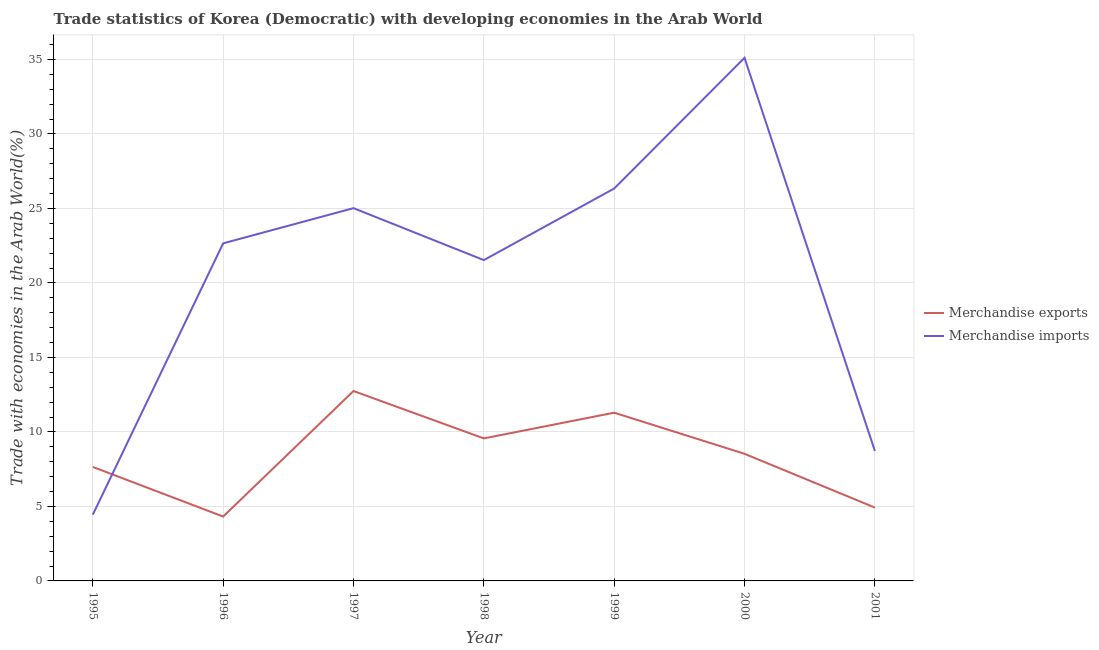How many different coloured lines are there?
Offer a terse response. 2. Does the line corresponding to merchandise exports intersect with the line corresponding to merchandise imports?
Your answer should be compact. Yes. What is the merchandise exports in 1996?
Your answer should be compact. 4.32. Across all years, what is the maximum merchandise imports?
Offer a very short reply. 35.11. Across all years, what is the minimum merchandise exports?
Your answer should be compact. 4.32. What is the total merchandise imports in the graph?
Provide a succinct answer. 143.83. What is the difference between the merchandise exports in 1996 and that in 2001?
Offer a very short reply. -0.6. What is the difference between the merchandise imports in 1998 and the merchandise exports in 1997?
Your answer should be compact. 8.79. What is the average merchandise imports per year?
Offer a terse response. 20.55. In the year 1996, what is the difference between the merchandise exports and merchandise imports?
Ensure brevity in your answer.  -18.34. What is the ratio of the merchandise exports in 1997 to that in 2000?
Provide a succinct answer. 1.49. Is the difference between the merchandise imports in 1999 and 2000 greater than the difference between the merchandise exports in 1999 and 2000?
Make the answer very short. No. What is the difference between the highest and the second highest merchandise exports?
Your answer should be compact. 1.45. What is the difference between the highest and the lowest merchandise exports?
Offer a terse response. 8.42. In how many years, is the merchandise exports greater than the average merchandise exports taken over all years?
Keep it short and to the point. 4. Is the sum of the merchandise exports in 1997 and 1998 greater than the maximum merchandise imports across all years?
Offer a terse response. No. Does the merchandise exports monotonically increase over the years?
Provide a succinct answer. No. How many years are there in the graph?
Offer a terse response. 7. Does the graph contain any zero values?
Your response must be concise. No. Where does the legend appear in the graph?
Ensure brevity in your answer.  Center right. How are the legend labels stacked?
Keep it short and to the point. Vertical. What is the title of the graph?
Your response must be concise. Trade statistics of Korea (Democratic) with developing economies in the Arab World. Does "Foreign Liabilities" appear as one of the legend labels in the graph?
Your answer should be compact. No. What is the label or title of the X-axis?
Make the answer very short. Year. What is the label or title of the Y-axis?
Offer a terse response. Trade with economies in the Arab World(%). What is the Trade with economies in the Arab World(%) in Merchandise exports in 1995?
Your answer should be very brief. 7.65. What is the Trade with economies in the Arab World(%) in Merchandise imports in 1995?
Make the answer very short. 4.45. What is the Trade with economies in the Arab World(%) of Merchandise exports in 1996?
Your response must be concise. 4.32. What is the Trade with economies in the Arab World(%) in Merchandise imports in 1996?
Your response must be concise. 22.66. What is the Trade with economies in the Arab World(%) in Merchandise exports in 1997?
Provide a succinct answer. 12.74. What is the Trade with economies in the Arab World(%) of Merchandise imports in 1997?
Give a very brief answer. 25.02. What is the Trade with economies in the Arab World(%) in Merchandise exports in 1998?
Provide a short and direct response. 9.57. What is the Trade with economies in the Arab World(%) in Merchandise imports in 1998?
Provide a succinct answer. 21.53. What is the Trade with economies in the Arab World(%) of Merchandise exports in 1999?
Your answer should be compact. 11.29. What is the Trade with economies in the Arab World(%) in Merchandise imports in 1999?
Keep it short and to the point. 26.34. What is the Trade with economies in the Arab World(%) of Merchandise exports in 2000?
Your answer should be very brief. 8.53. What is the Trade with economies in the Arab World(%) of Merchandise imports in 2000?
Offer a terse response. 35.11. What is the Trade with economies in the Arab World(%) of Merchandise exports in 2001?
Your answer should be very brief. 4.92. What is the Trade with economies in the Arab World(%) in Merchandise imports in 2001?
Give a very brief answer. 8.72. Across all years, what is the maximum Trade with economies in the Arab World(%) of Merchandise exports?
Provide a succinct answer. 12.74. Across all years, what is the maximum Trade with economies in the Arab World(%) of Merchandise imports?
Offer a very short reply. 35.11. Across all years, what is the minimum Trade with economies in the Arab World(%) in Merchandise exports?
Offer a very short reply. 4.32. Across all years, what is the minimum Trade with economies in the Arab World(%) of Merchandise imports?
Offer a terse response. 4.45. What is the total Trade with economies in the Arab World(%) of Merchandise exports in the graph?
Make the answer very short. 59.03. What is the total Trade with economies in the Arab World(%) in Merchandise imports in the graph?
Offer a very short reply. 143.83. What is the difference between the Trade with economies in the Arab World(%) in Merchandise exports in 1995 and that in 1996?
Give a very brief answer. 3.33. What is the difference between the Trade with economies in the Arab World(%) of Merchandise imports in 1995 and that in 1996?
Ensure brevity in your answer.  -18.21. What is the difference between the Trade with economies in the Arab World(%) in Merchandise exports in 1995 and that in 1997?
Make the answer very short. -5.1. What is the difference between the Trade with economies in the Arab World(%) in Merchandise imports in 1995 and that in 1997?
Ensure brevity in your answer.  -20.57. What is the difference between the Trade with economies in the Arab World(%) of Merchandise exports in 1995 and that in 1998?
Provide a short and direct response. -1.92. What is the difference between the Trade with economies in the Arab World(%) of Merchandise imports in 1995 and that in 1998?
Offer a very short reply. -17.08. What is the difference between the Trade with economies in the Arab World(%) in Merchandise exports in 1995 and that in 1999?
Provide a short and direct response. -3.64. What is the difference between the Trade with economies in the Arab World(%) in Merchandise imports in 1995 and that in 1999?
Keep it short and to the point. -21.89. What is the difference between the Trade with economies in the Arab World(%) of Merchandise exports in 1995 and that in 2000?
Make the answer very short. -0.88. What is the difference between the Trade with economies in the Arab World(%) of Merchandise imports in 1995 and that in 2000?
Offer a very short reply. -30.66. What is the difference between the Trade with economies in the Arab World(%) of Merchandise exports in 1995 and that in 2001?
Provide a succinct answer. 2.73. What is the difference between the Trade with economies in the Arab World(%) in Merchandise imports in 1995 and that in 2001?
Your response must be concise. -4.28. What is the difference between the Trade with economies in the Arab World(%) of Merchandise exports in 1996 and that in 1997?
Your answer should be very brief. -8.42. What is the difference between the Trade with economies in the Arab World(%) of Merchandise imports in 1996 and that in 1997?
Your response must be concise. -2.36. What is the difference between the Trade with economies in the Arab World(%) of Merchandise exports in 1996 and that in 1998?
Your answer should be very brief. -5.24. What is the difference between the Trade with economies in the Arab World(%) of Merchandise imports in 1996 and that in 1998?
Your answer should be very brief. 1.13. What is the difference between the Trade with economies in the Arab World(%) of Merchandise exports in 1996 and that in 1999?
Make the answer very short. -6.97. What is the difference between the Trade with economies in the Arab World(%) of Merchandise imports in 1996 and that in 1999?
Your answer should be very brief. -3.68. What is the difference between the Trade with economies in the Arab World(%) of Merchandise exports in 1996 and that in 2000?
Your answer should be very brief. -4.21. What is the difference between the Trade with economies in the Arab World(%) in Merchandise imports in 1996 and that in 2000?
Offer a very short reply. -12.45. What is the difference between the Trade with economies in the Arab World(%) of Merchandise exports in 1996 and that in 2001?
Give a very brief answer. -0.6. What is the difference between the Trade with economies in the Arab World(%) in Merchandise imports in 1996 and that in 2001?
Offer a very short reply. 13.93. What is the difference between the Trade with economies in the Arab World(%) of Merchandise exports in 1997 and that in 1998?
Your response must be concise. 3.18. What is the difference between the Trade with economies in the Arab World(%) in Merchandise imports in 1997 and that in 1998?
Give a very brief answer. 3.49. What is the difference between the Trade with economies in the Arab World(%) in Merchandise exports in 1997 and that in 1999?
Offer a very short reply. 1.45. What is the difference between the Trade with economies in the Arab World(%) of Merchandise imports in 1997 and that in 1999?
Offer a terse response. -1.32. What is the difference between the Trade with economies in the Arab World(%) in Merchandise exports in 1997 and that in 2000?
Give a very brief answer. 4.21. What is the difference between the Trade with economies in the Arab World(%) in Merchandise imports in 1997 and that in 2000?
Make the answer very short. -10.09. What is the difference between the Trade with economies in the Arab World(%) in Merchandise exports in 1997 and that in 2001?
Provide a short and direct response. 7.82. What is the difference between the Trade with economies in the Arab World(%) of Merchandise imports in 1997 and that in 2001?
Provide a succinct answer. 16.29. What is the difference between the Trade with economies in the Arab World(%) of Merchandise exports in 1998 and that in 1999?
Provide a short and direct response. -1.73. What is the difference between the Trade with economies in the Arab World(%) in Merchandise imports in 1998 and that in 1999?
Make the answer very short. -4.8. What is the difference between the Trade with economies in the Arab World(%) of Merchandise exports in 1998 and that in 2000?
Provide a succinct answer. 1.03. What is the difference between the Trade with economies in the Arab World(%) in Merchandise imports in 1998 and that in 2000?
Provide a short and direct response. -13.58. What is the difference between the Trade with economies in the Arab World(%) of Merchandise exports in 1998 and that in 2001?
Your answer should be compact. 4.64. What is the difference between the Trade with economies in the Arab World(%) of Merchandise imports in 1998 and that in 2001?
Your answer should be compact. 12.81. What is the difference between the Trade with economies in the Arab World(%) of Merchandise exports in 1999 and that in 2000?
Provide a succinct answer. 2.76. What is the difference between the Trade with economies in the Arab World(%) in Merchandise imports in 1999 and that in 2000?
Give a very brief answer. -8.77. What is the difference between the Trade with economies in the Arab World(%) of Merchandise exports in 1999 and that in 2001?
Make the answer very short. 6.37. What is the difference between the Trade with economies in the Arab World(%) in Merchandise imports in 1999 and that in 2001?
Offer a very short reply. 17.61. What is the difference between the Trade with economies in the Arab World(%) in Merchandise exports in 2000 and that in 2001?
Offer a terse response. 3.61. What is the difference between the Trade with economies in the Arab World(%) of Merchandise imports in 2000 and that in 2001?
Ensure brevity in your answer.  26.38. What is the difference between the Trade with economies in the Arab World(%) of Merchandise exports in 1995 and the Trade with economies in the Arab World(%) of Merchandise imports in 1996?
Make the answer very short. -15.01. What is the difference between the Trade with economies in the Arab World(%) in Merchandise exports in 1995 and the Trade with economies in the Arab World(%) in Merchandise imports in 1997?
Keep it short and to the point. -17.37. What is the difference between the Trade with economies in the Arab World(%) in Merchandise exports in 1995 and the Trade with economies in the Arab World(%) in Merchandise imports in 1998?
Offer a terse response. -13.88. What is the difference between the Trade with economies in the Arab World(%) in Merchandise exports in 1995 and the Trade with economies in the Arab World(%) in Merchandise imports in 1999?
Give a very brief answer. -18.69. What is the difference between the Trade with economies in the Arab World(%) in Merchandise exports in 1995 and the Trade with economies in the Arab World(%) in Merchandise imports in 2000?
Give a very brief answer. -27.46. What is the difference between the Trade with economies in the Arab World(%) in Merchandise exports in 1995 and the Trade with economies in the Arab World(%) in Merchandise imports in 2001?
Your answer should be compact. -1.08. What is the difference between the Trade with economies in the Arab World(%) in Merchandise exports in 1996 and the Trade with economies in the Arab World(%) in Merchandise imports in 1997?
Your answer should be compact. -20.7. What is the difference between the Trade with economies in the Arab World(%) in Merchandise exports in 1996 and the Trade with economies in the Arab World(%) in Merchandise imports in 1998?
Give a very brief answer. -17.21. What is the difference between the Trade with economies in the Arab World(%) in Merchandise exports in 1996 and the Trade with economies in the Arab World(%) in Merchandise imports in 1999?
Your answer should be compact. -22.02. What is the difference between the Trade with economies in the Arab World(%) of Merchandise exports in 1996 and the Trade with economies in the Arab World(%) of Merchandise imports in 2000?
Ensure brevity in your answer.  -30.79. What is the difference between the Trade with economies in the Arab World(%) of Merchandise exports in 1996 and the Trade with economies in the Arab World(%) of Merchandise imports in 2001?
Keep it short and to the point. -4.4. What is the difference between the Trade with economies in the Arab World(%) in Merchandise exports in 1997 and the Trade with economies in the Arab World(%) in Merchandise imports in 1998?
Keep it short and to the point. -8.79. What is the difference between the Trade with economies in the Arab World(%) of Merchandise exports in 1997 and the Trade with economies in the Arab World(%) of Merchandise imports in 1999?
Give a very brief answer. -13.59. What is the difference between the Trade with economies in the Arab World(%) of Merchandise exports in 1997 and the Trade with economies in the Arab World(%) of Merchandise imports in 2000?
Your answer should be compact. -22.36. What is the difference between the Trade with economies in the Arab World(%) in Merchandise exports in 1997 and the Trade with economies in the Arab World(%) in Merchandise imports in 2001?
Make the answer very short. 4.02. What is the difference between the Trade with economies in the Arab World(%) of Merchandise exports in 1998 and the Trade with economies in the Arab World(%) of Merchandise imports in 1999?
Offer a very short reply. -16.77. What is the difference between the Trade with economies in the Arab World(%) of Merchandise exports in 1998 and the Trade with economies in the Arab World(%) of Merchandise imports in 2000?
Provide a short and direct response. -25.54. What is the difference between the Trade with economies in the Arab World(%) of Merchandise exports in 1998 and the Trade with economies in the Arab World(%) of Merchandise imports in 2001?
Ensure brevity in your answer.  0.84. What is the difference between the Trade with economies in the Arab World(%) of Merchandise exports in 1999 and the Trade with economies in the Arab World(%) of Merchandise imports in 2000?
Ensure brevity in your answer.  -23.82. What is the difference between the Trade with economies in the Arab World(%) in Merchandise exports in 1999 and the Trade with economies in the Arab World(%) in Merchandise imports in 2001?
Keep it short and to the point. 2.57. What is the difference between the Trade with economies in the Arab World(%) of Merchandise exports in 2000 and the Trade with economies in the Arab World(%) of Merchandise imports in 2001?
Provide a succinct answer. -0.19. What is the average Trade with economies in the Arab World(%) in Merchandise exports per year?
Offer a very short reply. 8.43. What is the average Trade with economies in the Arab World(%) in Merchandise imports per year?
Give a very brief answer. 20.55. In the year 1995, what is the difference between the Trade with economies in the Arab World(%) in Merchandise exports and Trade with economies in the Arab World(%) in Merchandise imports?
Offer a terse response. 3.2. In the year 1996, what is the difference between the Trade with economies in the Arab World(%) in Merchandise exports and Trade with economies in the Arab World(%) in Merchandise imports?
Make the answer very short. -18.34. In the year 1997, what is the difference between the Trade with economies in the Arab World(%) of Merchandise exports and Trade with economies in the Arab World(%) of Merchandise imports?
Your answer should be compact. -12.27. In the year 1998, what is the difference between the Trade with economies in the Arab World(%) in Merchandise exports and Trade with economies in the Arab World(%) in Merchandise imports?
Provide a short and direct response. -11.97. In the year 1999, what is the difference between the Trade with economies in the Arab World(%) of Merchandise exports and Trade with economies in the Arab World(%) of Merchandise imports?
Give a very brief answer. -15.05. In the year 2000, what is the difference between the Trade with economies in the Arab World(%) of Merchandise exports and Trade with economies in the Arab World(%) of Merchandise imports?
Keep it short and to the point. -26.58. In the year 2001, what is the difference between the Trade with economies in the Arab World(%) of Merchandise exports and Trade with economies in the Arab World(%) of Merchandise imports?
Make the answer very short. -3.8. What is the ratio of the Trade with economies in the Arab World(%) in Merchandise exports in 1995 to that in 1996?
Your answer should be very brief. 1.77. What is the ratio of the Trade with economies in the Arab World(%) in Merchandise imports in 1995 to that in 1996?
Give a very brief answer. 0.2. What is the ratio of the Trade with economies in the Arab World(%) in Merchandise exports in 1995 to that in 1997?
Your response must be concise. 0.6. What is the ratio of the Trade with economies in the Arab World(%) in Merchandise imports in 1995 to that in 1997?
Give a very brief answer. 0.18. What is the ratio of the Trade with economies in the Arab World(%) in Merchandise exports in 1995 to that in 1998?
Give a very brief answer. 0.8. What is the ratio of the Trade with economies in the Arab World(%) in Merchandise imports in 1995 to that in 1998?
Make the answer very short. 0.21. What is the ratio of the Trade with economies in the Arab World(%) in Merchandise exports in 1995 to that in 1999?
Your answer should be very brief. 0.68. What is the ratio of the Trade with economies in the Arab World(%) in Merchandise imports in 1995 to that in 1999?
Provide a succinct answer. 0.17. What is the ratio of the Trade with economies in the Arab World(%) of Merchandise exports in 1995 to that in 2000?
Your answer should be compact. 0.9. What is the ratio of the Trade with economies in the Arab World(%) of Merchandise imports in 1995 to that in 2000?
Give a very brief answer. 0.13. What is the ratio of the Trade with economies in the Arab World(%) of Merchandise exports in 1995 to that in 2001?
Make the answer very short. 1.55. What is the ratio of the Trade with economies in the Arab World(%) of Merchandise imports in 1995 to that in 2001?
Offer a very short reply. 0.51. What is the ratio of the Trade with economies in the Arab World(%) of Merchandise exports in 1996 to that in 1997?
Ensure brevity in your answer.  0.34. What is the ratio of the Trade with economies in the Arab World(%) of Merchandise imports in 1996 to that in 1997?
Your answer should be very brief. 0.91. What is the ratio of the Trade with economies in the Arab World(%) of Merchandise exports in 1996 to that in 1998?
Provide a succinct answer. 0.45. What is the ratio of the Trade with economies in the Arab World(%) of Merchandise imports in 1996 to that in 1998?
Your answer should be very brief. 1.05. What is the ratio of the Trade with economies in the Arab World(%) in Merchandise exports in 1996 to that in 1999?
Offer a terse response. 0.38. What is the ratio of the Trade with economies in the Arab World(%) of Merchandise imports in 1996 to that in 1999?
Ensure brevity in your answer.  0.86. What is the ratio of the Trade with economies in the Arab World(%) in Merchandise exports in 1996 to that in 2000?
Ensure brevity in your answer.  0.51. What is the ratio of the Trade with economies in the Arab World(%) of Merchandise imports in 1996 to that in 2000?
Give a very brief answer. 0.65. What is the ratio of the Trade with economies in the Arab World(%) in Merchandise exports in 1996 to that in 2001?
Ensure brevity in your answer.  0.88. What is the ratio of the Trade with economies in the Arab World(%) of Merchandise imports in 1996 to that in 2001?
Make the answer very short. 2.6. What is the ratio of the Trade with economies in the Arab World(%) of Merchandise exports in 1997 to that in 1998?
Your response must be concise. 1.33. What is the ratio of the Trade with economies in the Arab World(%) in Merchandise imports in 1997 to that in 1998?
Offer a terse response. 1.16. What is the ratio of the Trade with economies in the Arab World(%) in Merchandise exports in 1997 to that in 1999?
Offer a very short reply. 1.13. What is the ratio of the Trade with economies in the Arab World(%) in Merchandise imports in 1997 to that in 1999?
Offer a terse response. 0.95. What is the ratio of the Trade with economies in the Arab World(%) of Merchandise exports in 1997 to that in 2000?
Make the answer very short. 1.49. What is the ratio of the Trade with economies in the Arab World(%) in Merchandise imports in 1997 to that in 2000?
Offer a very short reply. 0.71. What is the ratio of the Trade with economies in the Arab World(%) in Merchandise exports in 1997 to that in 2001?
Offer a terse response. 2.59. What is the ratio of the Trade with economies in the Arab World(%) of Merchandise imports in 1997 to that in 2001?
Your response must be concise. 2.87. What is the ratio of the Trade with economies in the Arab World(%) in Merchandise exports in 1998 to that in 1999?
Offer a very short reply. 0.85. What is the ratio of the Trade with economies in the Arab World(%) of Merchandise imports in 1998 to that in 1999?
Provide a short and direct response. 0.82. What is the ratio of the Trade with economies in the Arab World(%) of Merchandise exports in 1998 to that in 2000?
Give a very brief answer. 1.12. What is the ratio of the Trade with economies in the Arab World(%) of Merchandise imports in 1998 to that in 2000?
Offer a terse response. 0.61. What is the ratio of the Trade with economies in the Arab World(%) of Merchandise exports in 1998 to that in 2001?
Give a very brief answer. 1.94. What is the ratio of the Trade with economies in the Arab World(%) in Merchandise imports in 1998 to that in 2001?
Ensure brevity in your answer.  2.47. What is the ratio of the Trade with economies in the Arab World(%) in Merchandise exports in 1999 to that in 2000?
Provide a succinct answer. 1.32. What is the ratio of the Trade with economies in the Arab World(%) in Merchandise imports in 1999 to that in 2000?
Your response must be concise. 0.75. What is the ratio of the Trade with economies in the Arab World(%) of Merchandise exports in 1999 to that in 2001?
Your answer should be very brief. 2.29. What is the ratio of the Trade with economies in the Arab World(%) of Merchandise imports in 1999 to that in 2001?
Make the answer very short. 3.02. What is the ratio of the Trade with economies in the Arab World(%) of Merchandise exports in 2000 to that in 2001?
Your answer should be very brief. 1.73. What is the ratio of the Trade with economies in the Arab World(%) of Merchandise imports in 2000 to that in 2001?
Provide a succinct answer. 4.02. What is the difference between the highest and the second highest Trade with economies in the Arab World(%) in Merchandise exports?
Provide a succinct answer. 1.45. What is the difference between the highest and the second highest Trade with economies in the Arab World(%) in Merchandise imports?
Make the answer very short. 8.77. What is the difference between the highest and the lowest Trade with economies in the Arab World(%) in Merchandise exports?
Offer a terse response. 8.42. What is the difference between the highest and the lowest Trade with economies in the Arab World(%) in Merchandise imports?
Your response must be concise. 30.66. 